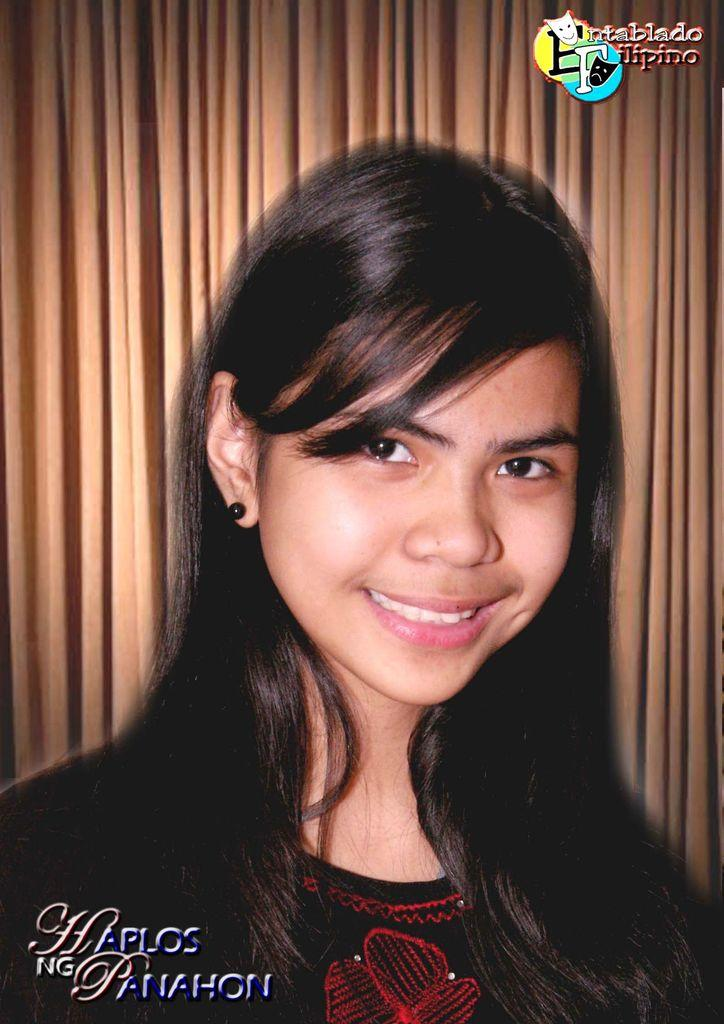Who is the main subject in the picture? There is a girl in the picture. What is the girl wearing? The girl is wearing a black t-shirt. What is the girl's facial expression in the picture? The girl is smiling. What is the girl doing in the picture? The girl is giving a pose into the camera. What can be seen in the background of the image? There is a brown curtain in the background of the image. Are there any visible imperfections on the image? Yes, there are water marks visible on the image. How much water is being used by the waves in the image? There are no waves present in the image, so it is not possible to determine the amount of water being used. 